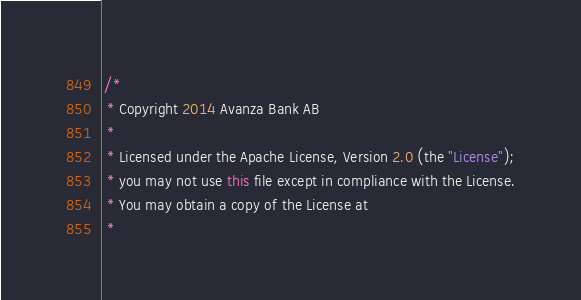Convert code to text. <code><loc_0><loc_0><loc_500><loc_500><_Java_>/*
 * Copyright 2014 Avanza Bank AB
 *
 * Licensed under the Apache License, Version 2.0 (the "License");
 * you may not use this file except in compliance with the License.
 * You may obtain a copy of the License at
 *</code> 